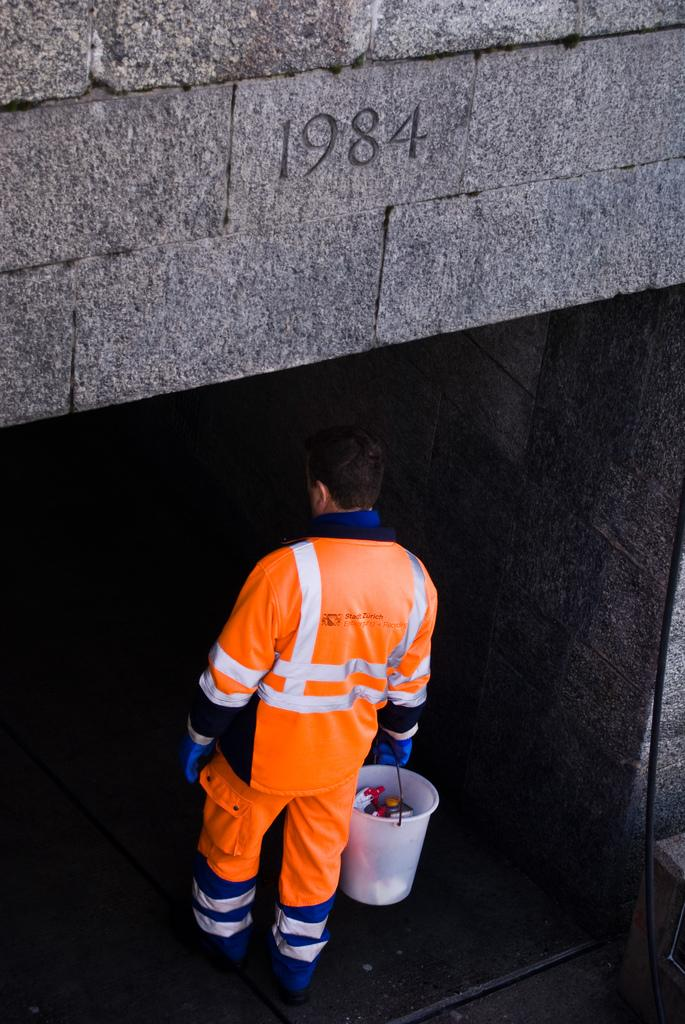<image>
Offer a succinct explanation of the picture presented. A man in an orange safety outfit is below a stone wall that says 1984 on it. 